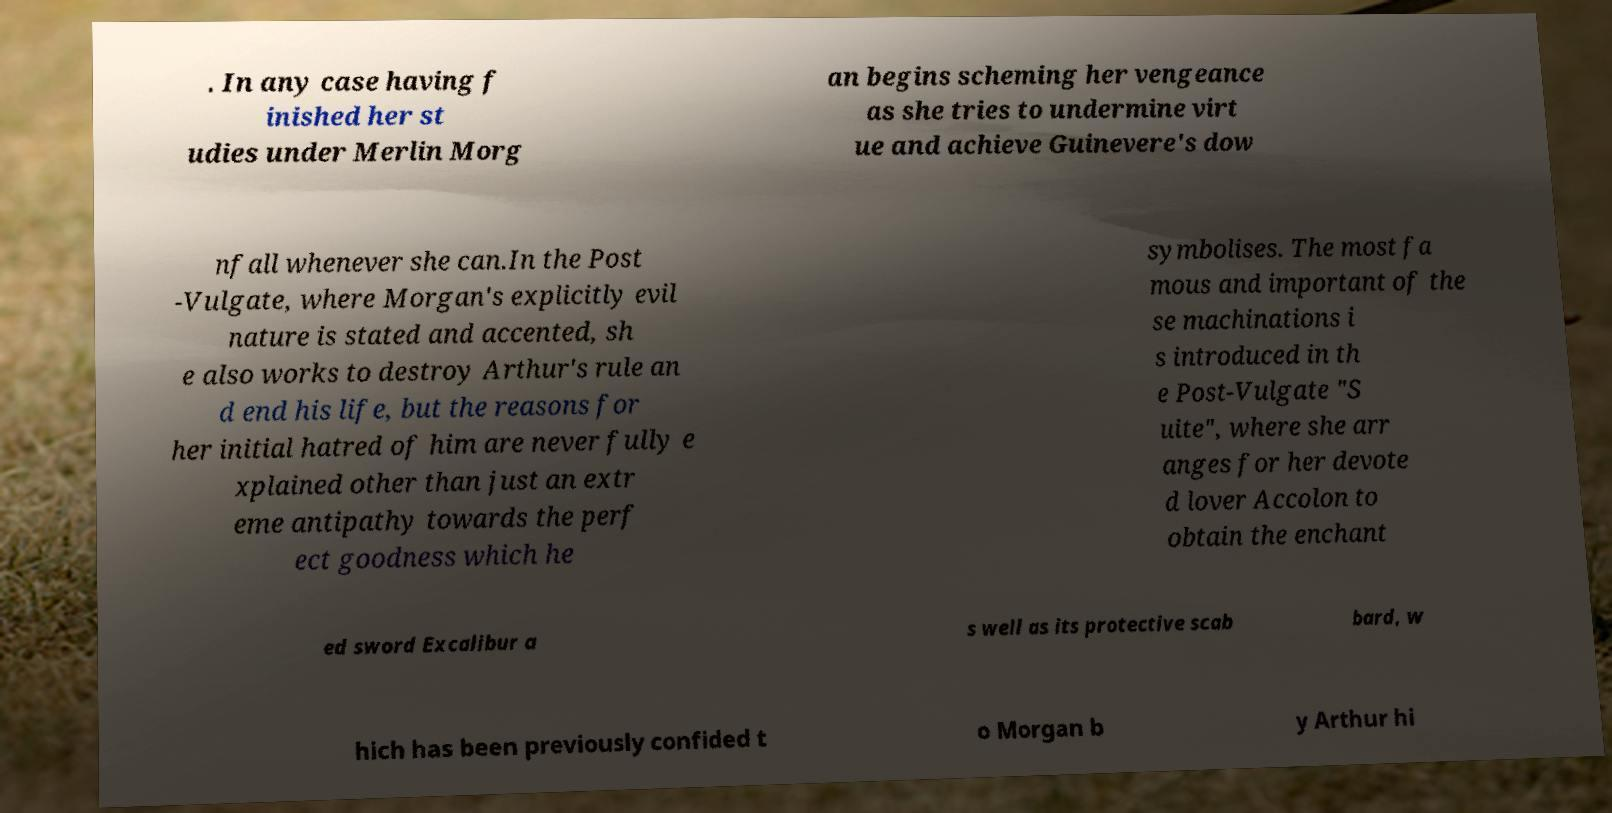What messages or text are displayed in this image? I need them in a readable, typed format. . In any case having f inished her st udies under Merlin Morg an begins scheming her vengeance as she tries to undermine virt ue and achieve Guinevere's dow nfall whenever she can.In the Post -Vulgate, where Morgan's explicitly evil nature is stated and accented, sh e also works to destroy Arthur's rule an d end his life, but the reasons for her initial hatred of him are never fully e xplained other than just an extr eme antipathy towards the perf ect goodness which he symbolises. The most fa mous and important of the se machinations i s introduced in th e Post-Vulgate "S uite", where she arr anges for her devote d lover Accolon to obtain the enchant ed sword Excalibur a s well as its protective scab bard, w hich has been previously confided t o Morgan b y Arthur hi 